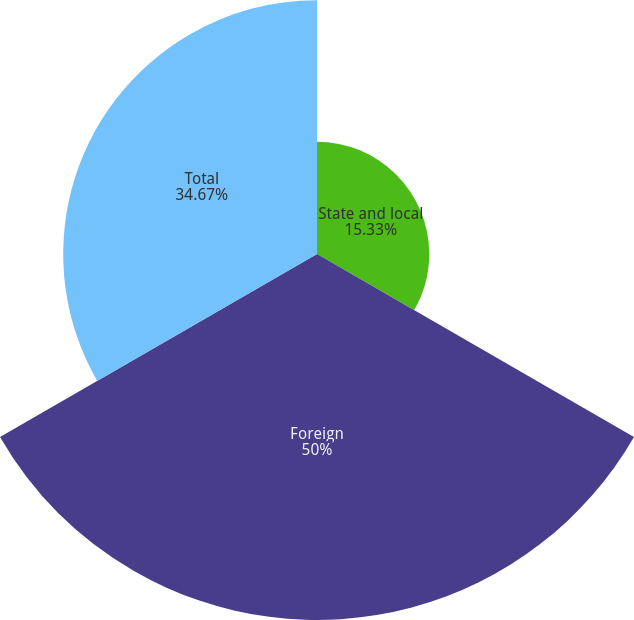<chart> <loc_0><loc_0><loc_500><loc_500><pie_chart><fcel>State and local<fcel>Foreign<fcel>Total<nl><fcel>15.33%<fcel>50.0%<fcel>34.67%<nl></chart> 